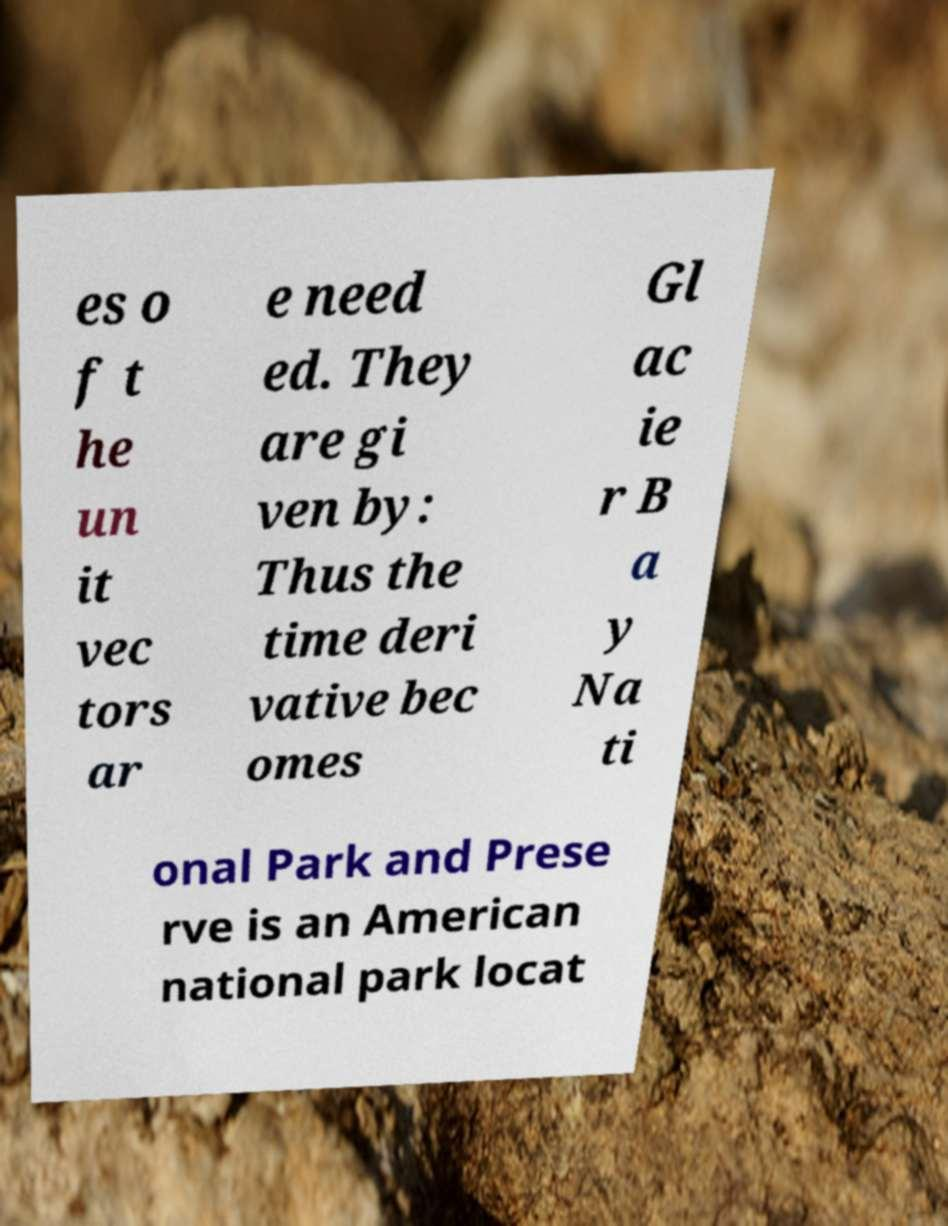For documentation purposes, I need the text within this image transcribed. Could you provide that? es o f t he un it vec tors ar e need ed. They are gi ven by: Thus the time deri vative bec omes Gl ac ie r B a y Na ti onal Park and Prese rve is an American national park locat 